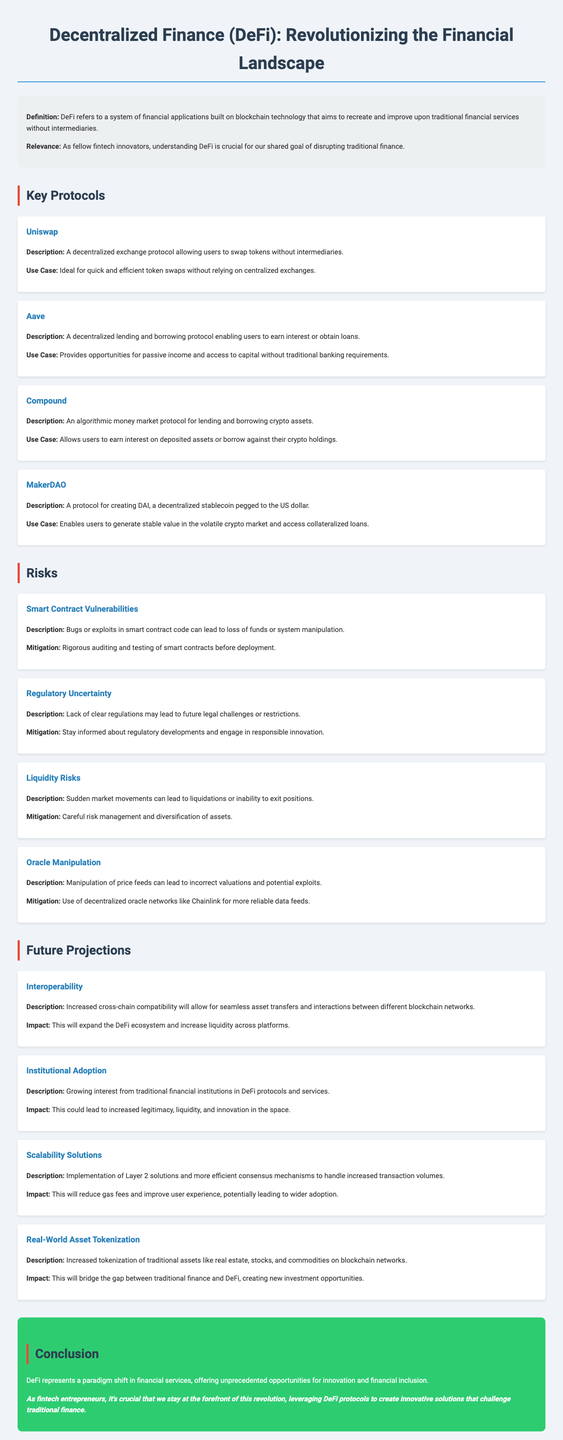what is the title of the document? The title is clearly stated at the top of the document.
Answer: Decentralized Finance (DeFi): Revolutionizing the Financial Landscape what is DeFi? The definition of DeFi is provided in the introduction section of the document.
Answer: A system of financial applications built on blockchain technology that aims to recreate and improve upon traditional financial services without intermediaries name one key protocol for decentralized exchanges. This information can be found in the key protocols section of the document.
Answer: Uniswap what is one risk associated with smart contracts? The document lists specific risks, including those associated with smart contracts.
Answer: Bugs or exploits in smart contract code can lead to loss of funds or system manipulation what is the impact of interoperability in DeFi? The document describes the anticipated effects of interoperability on the DeFi ecosystem.
Answer: This will expand the DeFi ecosystem and increase liquidity across platforms which protocol allows users to generate DAI? This can be identified in the key protocols section mentioning specific functionalities.
Answer: MakerDAO how does Aave benefit users? The use case for Aave is specified in the key protocols section.
Answer: Provides opportunities for passive income and access to capital without traditional banking requirements what is the trend related to asset tokenization? The document lists future projections, including trends in asset tokenization.
Answer: Increased tokenization of traditional assets like real estate, stocks, and commodities on blockchain networks 